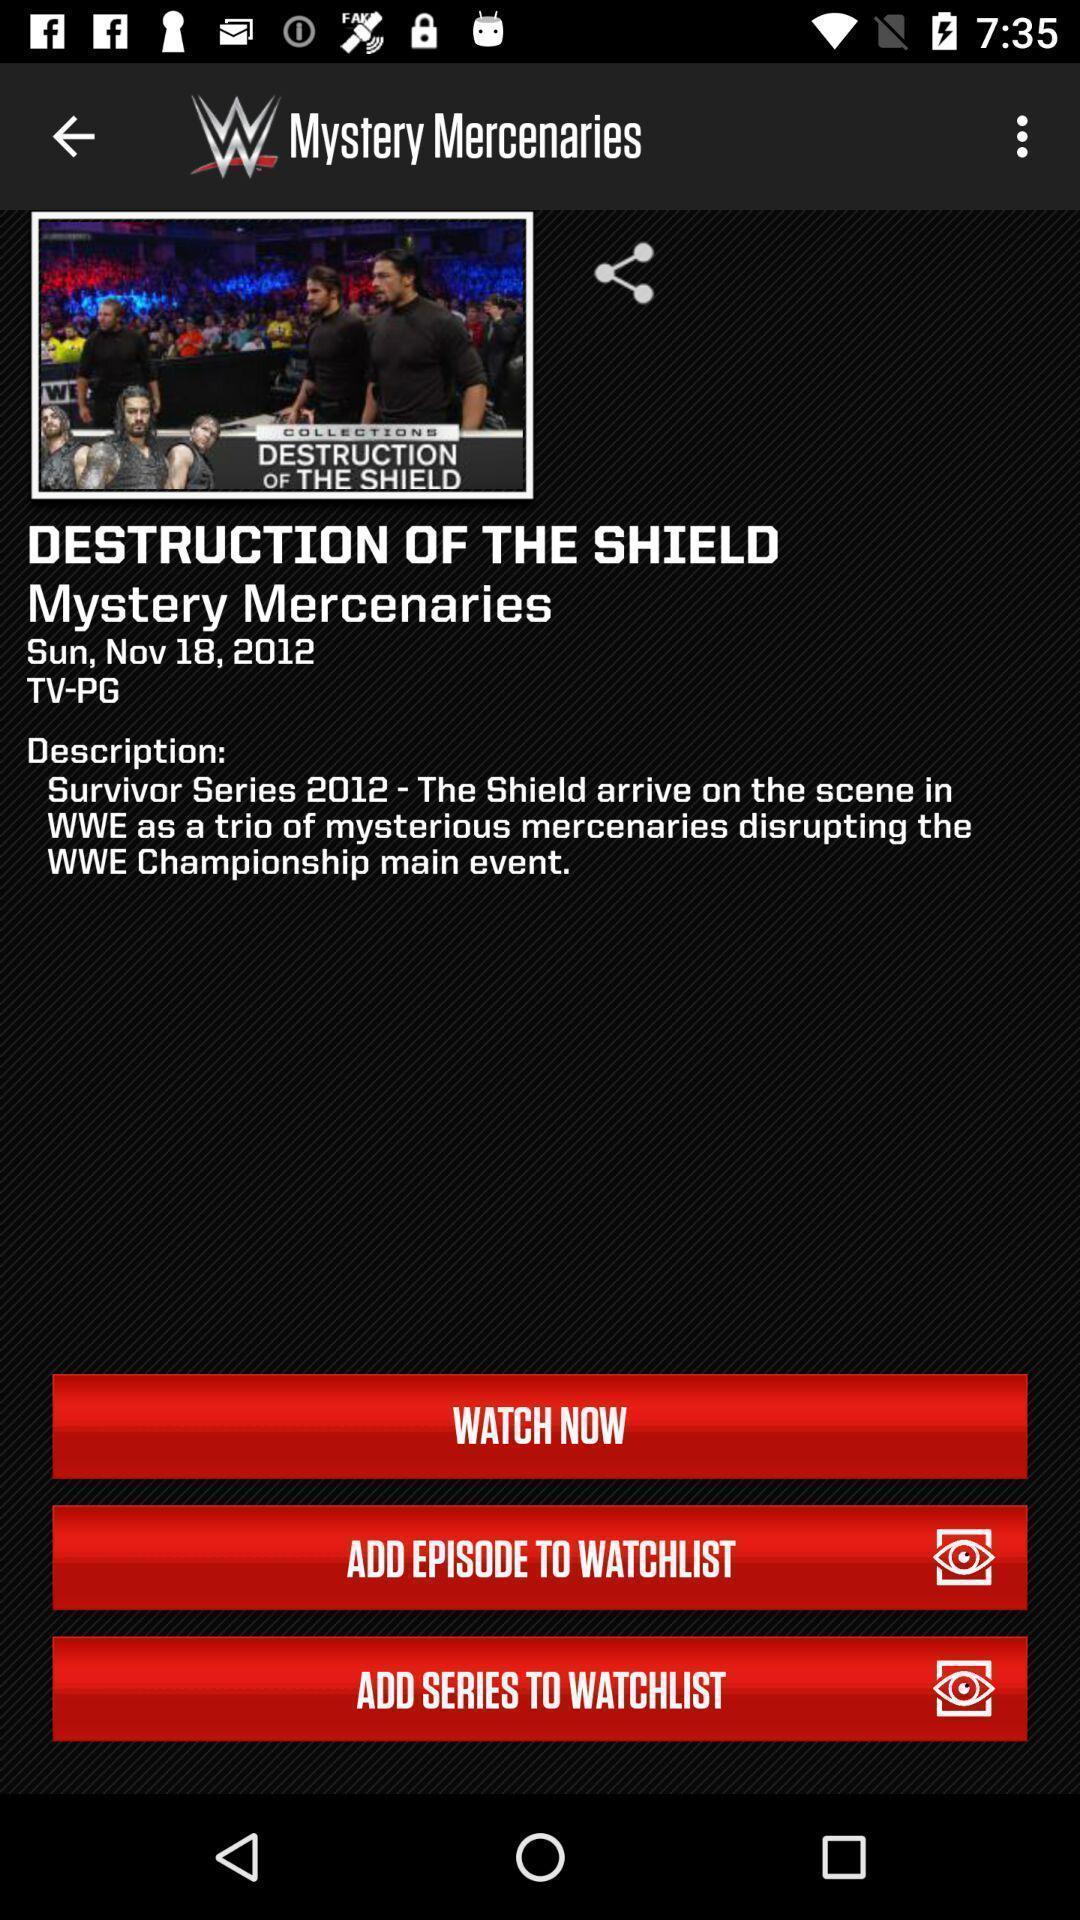What can you discern from this picture? Page displaying to watch a episode in app. 